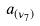<formula> <loc_0><loc_0><loc_500><loc_500>a _ { ( \nu _ { 7 } ) }</formula> 